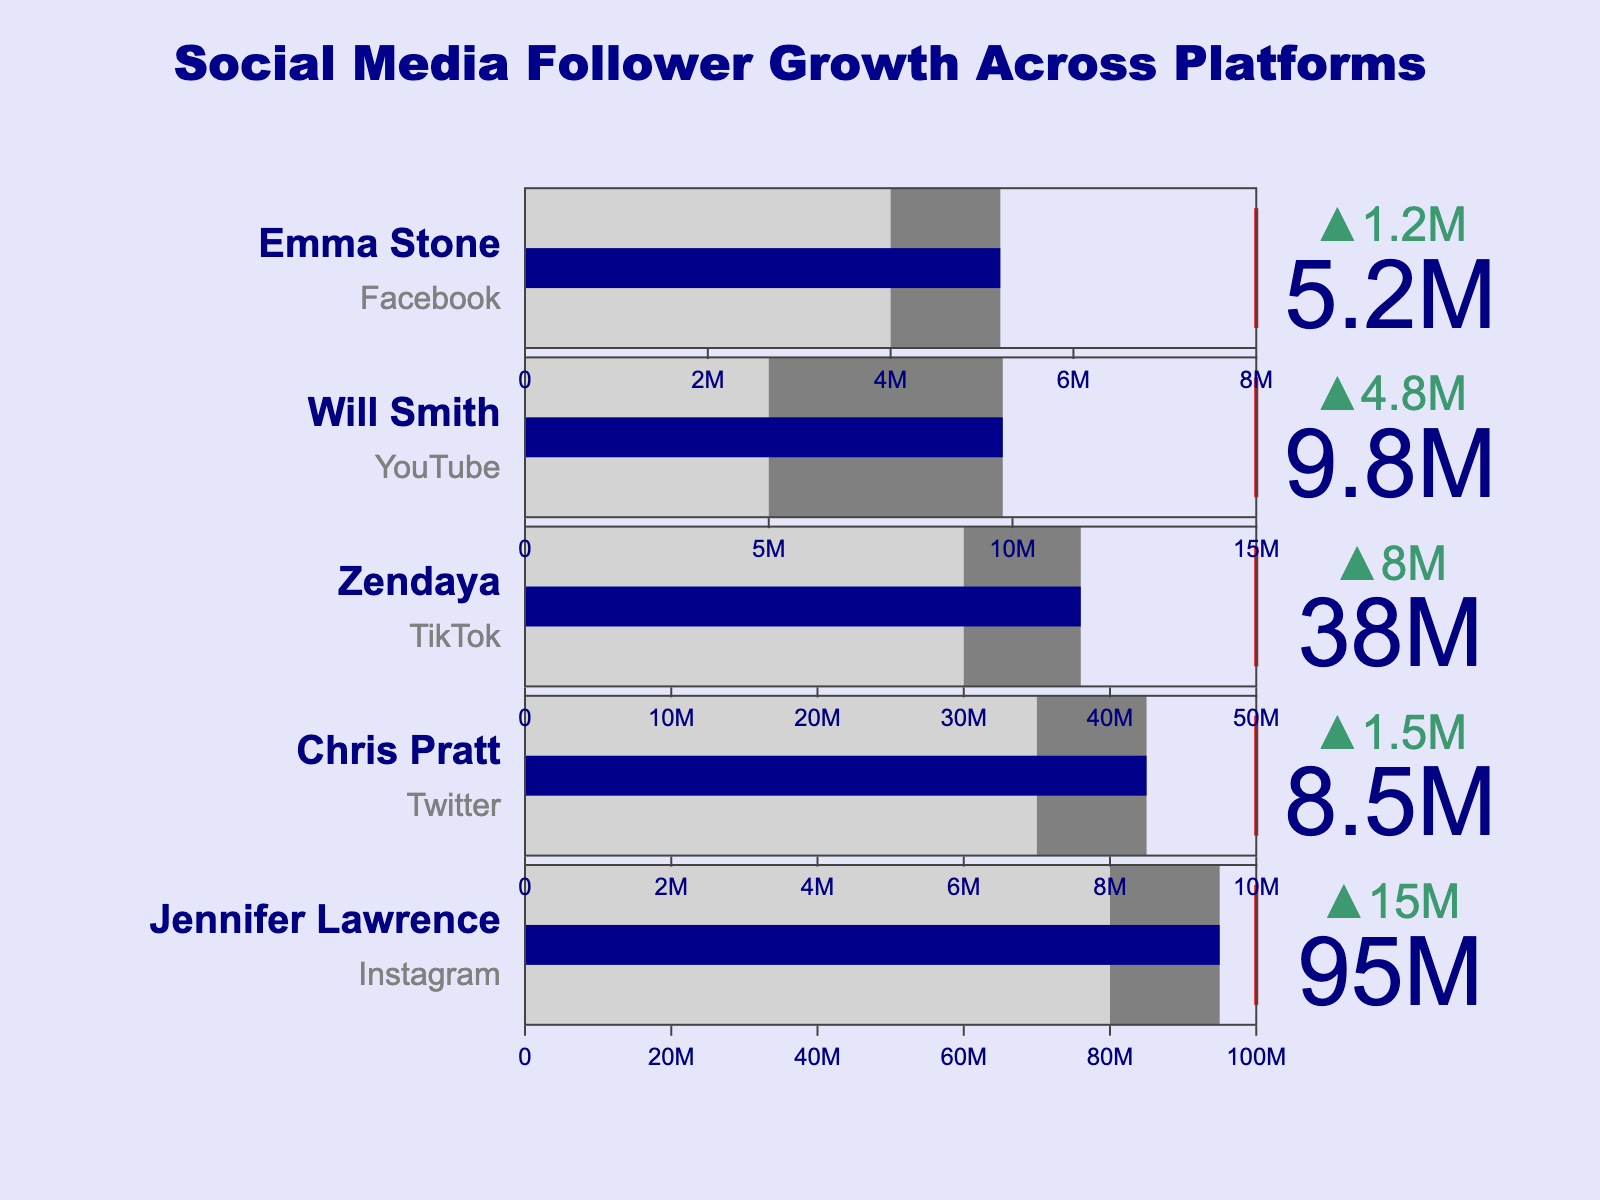Which celebrity has the highest current follower count? Jennifer Lawrence has the highest current follower count, as shown by the largest bar on Instagram with a value of 95,000,000.
Answer: Jennifer Lawrence Who is closest to reaching their target follower count? Jennifer Lawrence is closest to reaching her target, as her current number is 95,000,000 followers compared to her target of 100,000,000 on Instagram, making the difference 5,000,000 followers.
Answer: Jennifer Lawrence Which social media platform does Will Smith primarily use, according to this chart? Will Smith primarily uses YouTube, as indicated by the title of his bullet chart.
Answer: YouTube How many followers does Zendaya need to reach her target on TikTok? Zendaya currently has 38,000,000 followers and her target is 50,000,000, so she needs 50,000,000 - 38,000,000 = 12,000,000 followers to reach her target.
Answer: 12,000,000 What is the difference between Chris Pratt's current followers and the average followers for his platform? Chris Pratt's current followers on Twitter are 8,500,000 and the average is 7,000,000. The difference is 8,500,000 - 7,000,000 = 1,500,000 followers.
Answer: 1,500,000 Who has the highest target follower count among the celebrities? Will Smith has the highest target follower count on YouTube, which is 15,000,000 followers as indicated by the red threshold line.
Answer: Will Smith Which celebrity's current followers exceed the average followers by the largest margin? Jennifer Lawrence exceeds the average followers on Instagram by the largest margin. She has 95,000,000 current followers and the average is 80,000,000, making the margin 95,000,000 - 80,000,000 = 15,000,000 followers.
Answer: Jennifer Lawrence Which celebrity has the fewest current followers? Emma Stone has the fewest current followers on Facebook, with a total of 5,200,000.
Answer: Emma Stone How far short is Emma Stone from her target followers on Facebook? Emma Stone's target on Facebook is 8,000,000 followers. She currently has 5,200,000 followers, so she is 8,000,000 - 5,200,000 = 2,800,000 followers short of her target.
Answer: 2,800,000 